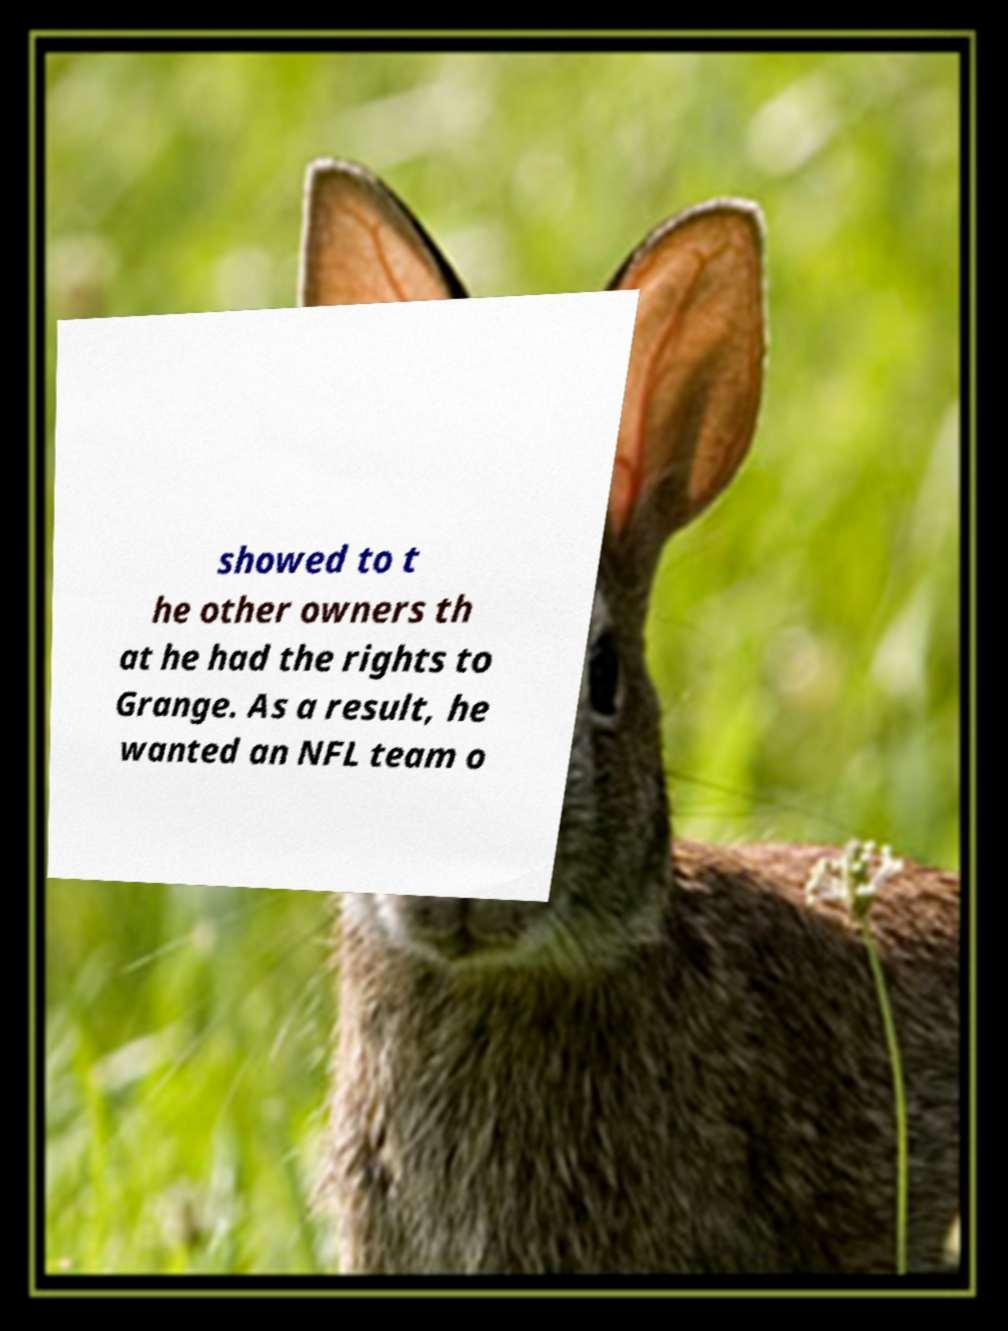Could you extract and type out the text from this image? showed to t he other owners th at he had the rights to Grange. As a result, he wanted an NFL team o 